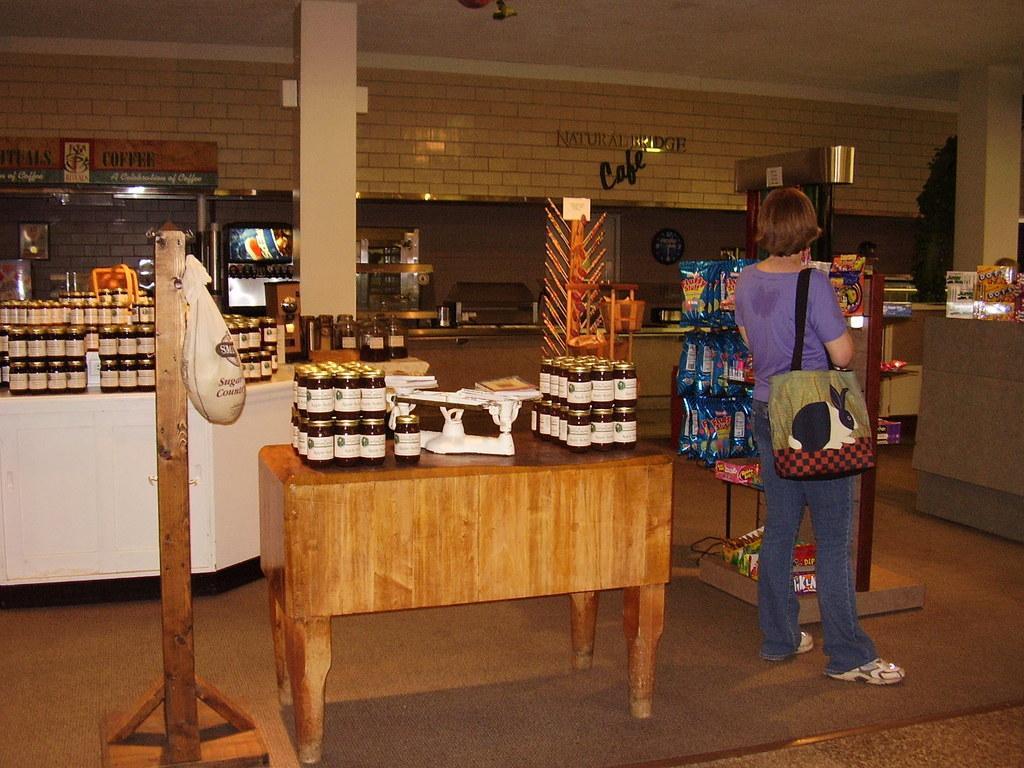Please provide a concise description of this image. This is a room,in which there are few bottles on the table and a woman is standing on the floor. 